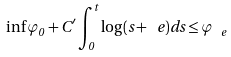<formula> <loc_0><loc_0><loc_500><loc_500>\inf \varphi _ { 0 } + C ^ { \prime } \int _ { 0 } ^ { t } \log ( s + \ e ) d s \leq \varphi _ { \ e }</formula> 